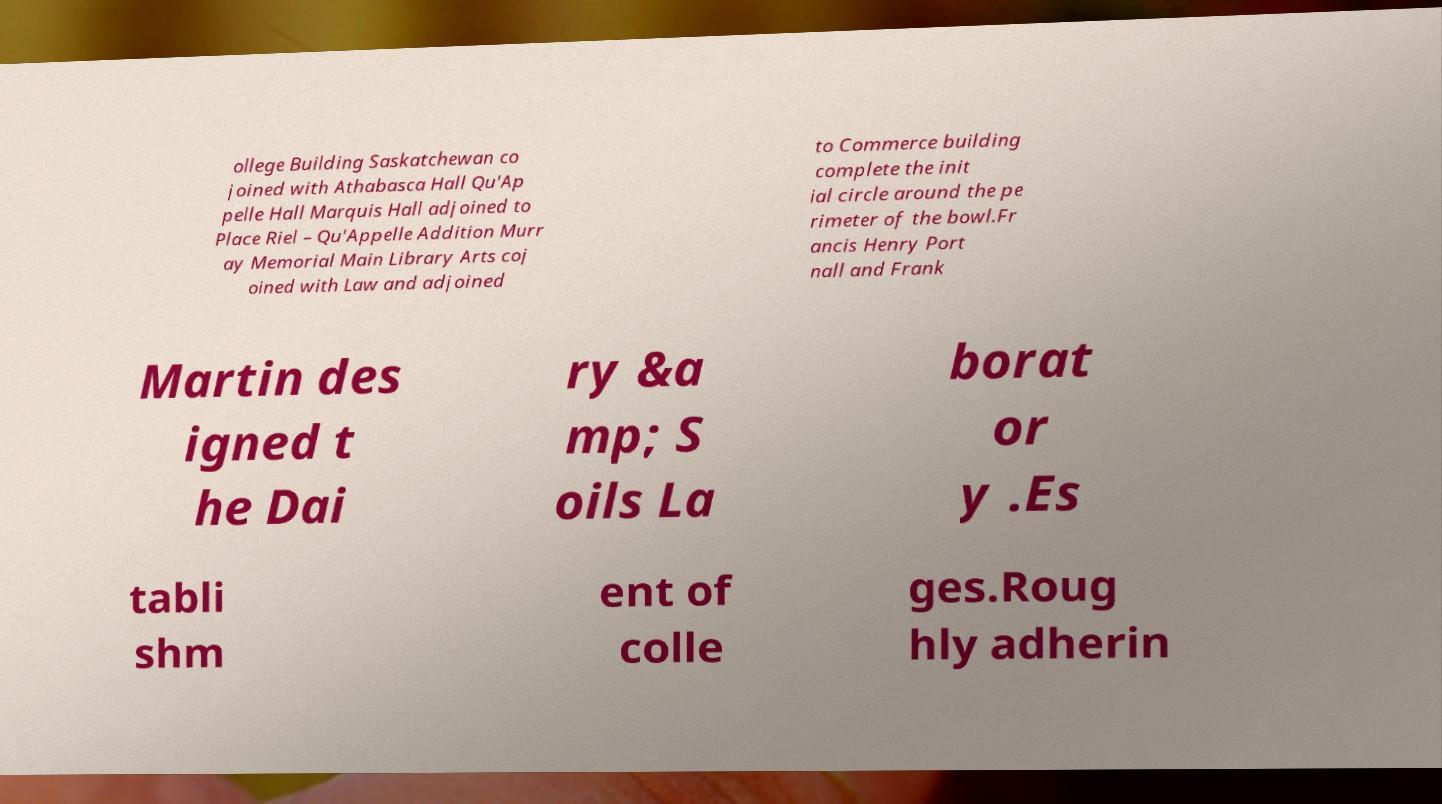Please identify and transcribe the text found in this image. ollege Building Saskatchewan co joined with Athabasca Hall Qu'Ap pelle Hall Marquis Hall adjoined to Place Riel – Qu'Appelle Addition Murr ay Memorial Main Library Arts coj oined with Law and adjoined to Commerce building complete the init ial circle around the pe rimeter of the bowl.Fr ancis Henry Port nall and Frank Martin des igned t he Dai ry &a mp; S oils La borat or y .Es tabli shm ent of colle ges.Roug hly adherin 